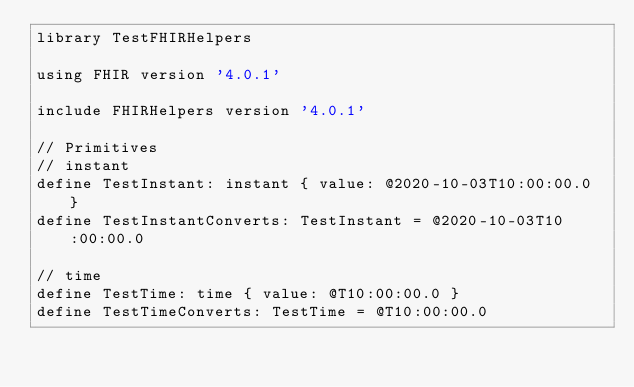Convert code to text. <code><loc_0><loc_0><loc_500><loc_500><_SQL_>library TestFHIRHelpers

using FHIR version '4.0.1'

include FHIRHelpers version '4.0.1'

// Primitives
// instant
define TestInstant: instant { value: @2020-10-03T10:00:00.0 }
define TestInstantConverts: TestInstant = @2020-10-03T10:00:00.0

// time
define TestTime: time { value: @T10:00:00.0 }
define TestTimeConverts: TestTime = @T10:00:00.0</code> 